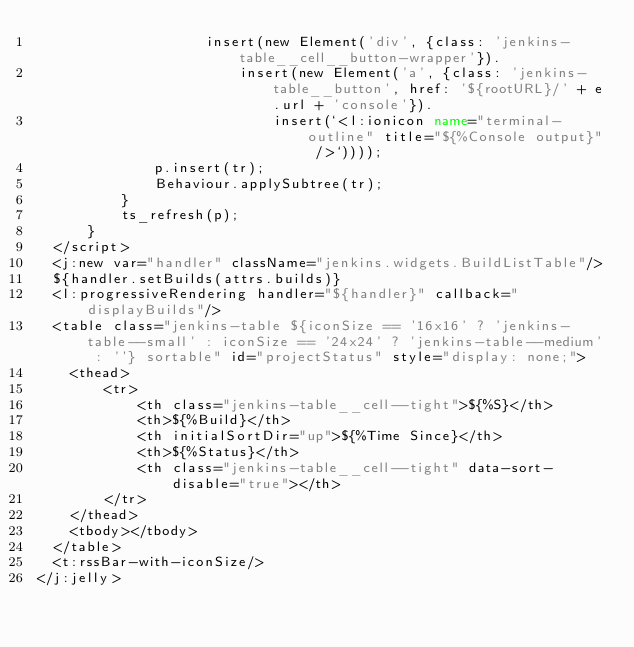Convert code to text. <code><loc_0><loc_0><loc_500><loc_500><_XML_>                    insert(new Element('div', {class: 'jenkins-table__cell__button-wrapper'}).
                        insert(new Element('a', {class: 'jenkins-table__button', href: '${rootURL}/' + e.url + 'console'}).
                            insert(`<l:ionicon name="terminal-outline" title="${%Console output}" />`))));
              p.insert(tr);
              Behaviour.applySubtree(tr);
          }
          ts_refresh(p);
      }
  </script>
  <j:new var="handler" className="jenkins.widgets.BuildListTable"/>
  ${handler.setBuilds(attrs.builds)}
  <l:progressiveRendering handler="${handler}" callback="displayBuilds"/>
  <table class="jenkins-table ${iconSize == '16x16' ? 'jenkins-table--small' : iconSize == '24x24' ? 'jenkins-table--medium' : ''} sortable" id="projectStatus" style="display: none;">
    <thead>
        <tr>
            <th class="jenkins-table__cell--tight">${%S}</th>
            <th>${%Build}</th>
            <th initialSortDir="up">${%Time Since}</th>
            <th>${%Status}</th>
            <th class="jenkins-table__cell--tight" data-sort-disable="true"></th>
        </tr>
    </thead>
    <tbody></tbody>
  </table>
  <t:rssBar-with-iconSize/>
</j:jelly>
</code> 